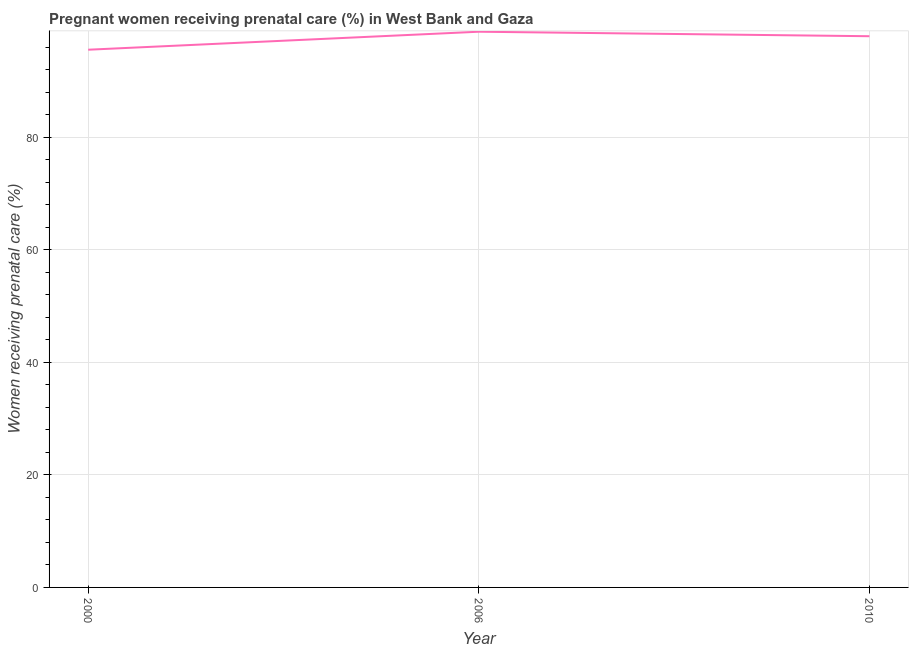Across all years, what is the maximum percentage of pregnant women receiving prenatal care?
Ensure brevity in your answer.  98.8. Across all years, what is the minimum percentage of pregnant women receiving prenatal care?
Offer a very short reply. 95.6. In which year was the percentage of pregnant women receiving prenatal care maximum?
Your response must be concise. 2006. In which year was the percentage of pregnant women receiving prenatal care minimum?
Provide a succinct answer. 2000. What is the sum of the percentage of pregnant women receiving prenatal care?
Provide a succinct answer. 292.4. What is the difference between the percentage of pregnant women receiving prenatal care in 2000 and 2006?
Ensure brevity in your answer.  -3.2. What is the average percentage of pregnant women receiving prenatal care per year?
Offer a terse response. 97.47. What is the median percentage of pregnant women receiving prenatal care?
Keep it short and to the point. 98. In how many years, is the percentage of pregnant women receiving prenatal care greater than 80 %?
Your response must be concise. 3. What is the ratio of the percentage of pregnant women receiving prenatal care in 2006 to that in 2010?
Your answer should be very brief. 1.01. Is the difference between the percentage of pregnant women receiving prenatal care in 2000 and 2006 greater than the difference between any two years?
Your answer should be very brief. Yes. What is the difference between the highest and the second highest percentage of pregnant women receiving prenatal care?
Make the answer very short. 0.8. Is the sum of the percentage of pregnant women receiving prenatal care in 2000 and 2006 greater than the maximum percentage of pregnant women receiving prenatal care across all years?
Offer a very short reply. Yes. What is the difference between the highest and the lowest percentage of pregnant women receiving prenatal care?
Offer a terse response. 3.2. In how many years, is the percentage of pregnant women receiving prenatal care greater than the average percentage of pregnant women receiving prenatal care taken over all years?
Offer a very short reply. 2. Does the percentage of pregnant women receiving prenatal care monotonically increase over the years?
Your response must be concise. No. How many years are there in the graph?
Offer a terse response. 3. What is the difference between two consecutive major ticks on the Y-axis?
Provide a short and direct response. 20. Does the graph contain grids?
Give a very brief answer. Yes. What is the title of the graph?
Your answer should be compact. Pregnant women receiving prenatal care (%) in West Bank and Gaza. What is the label or title of the X-axis?
Keep it short and to the point. Year. What is the label or title of the Y-axis?
Your response must be concise. Women receiving prenatal care (%). What is the Women receiving prenatal care (%) in 2000?
Keep it short and to the point. 95.6. What is the Women receiving prenatal care (%) in 2006?
Offer a very short reply. 98.8. What is the Women receiving prenatal care (%) of 2010?
Provide a short and direct response. 98. What is the difference between the Women receiving prenatal care (%) in 2000 and 2006?
Your answer should be compact. -3.2. What is the difference between the Women receiving prenatal care (%) in 2006 and 2010?
Make the answer very short. 0.8. What is the ratio of the Women receiving prenatal care (%) in 2000 to that in 2006?
Offer a very short reply. 0.97. 